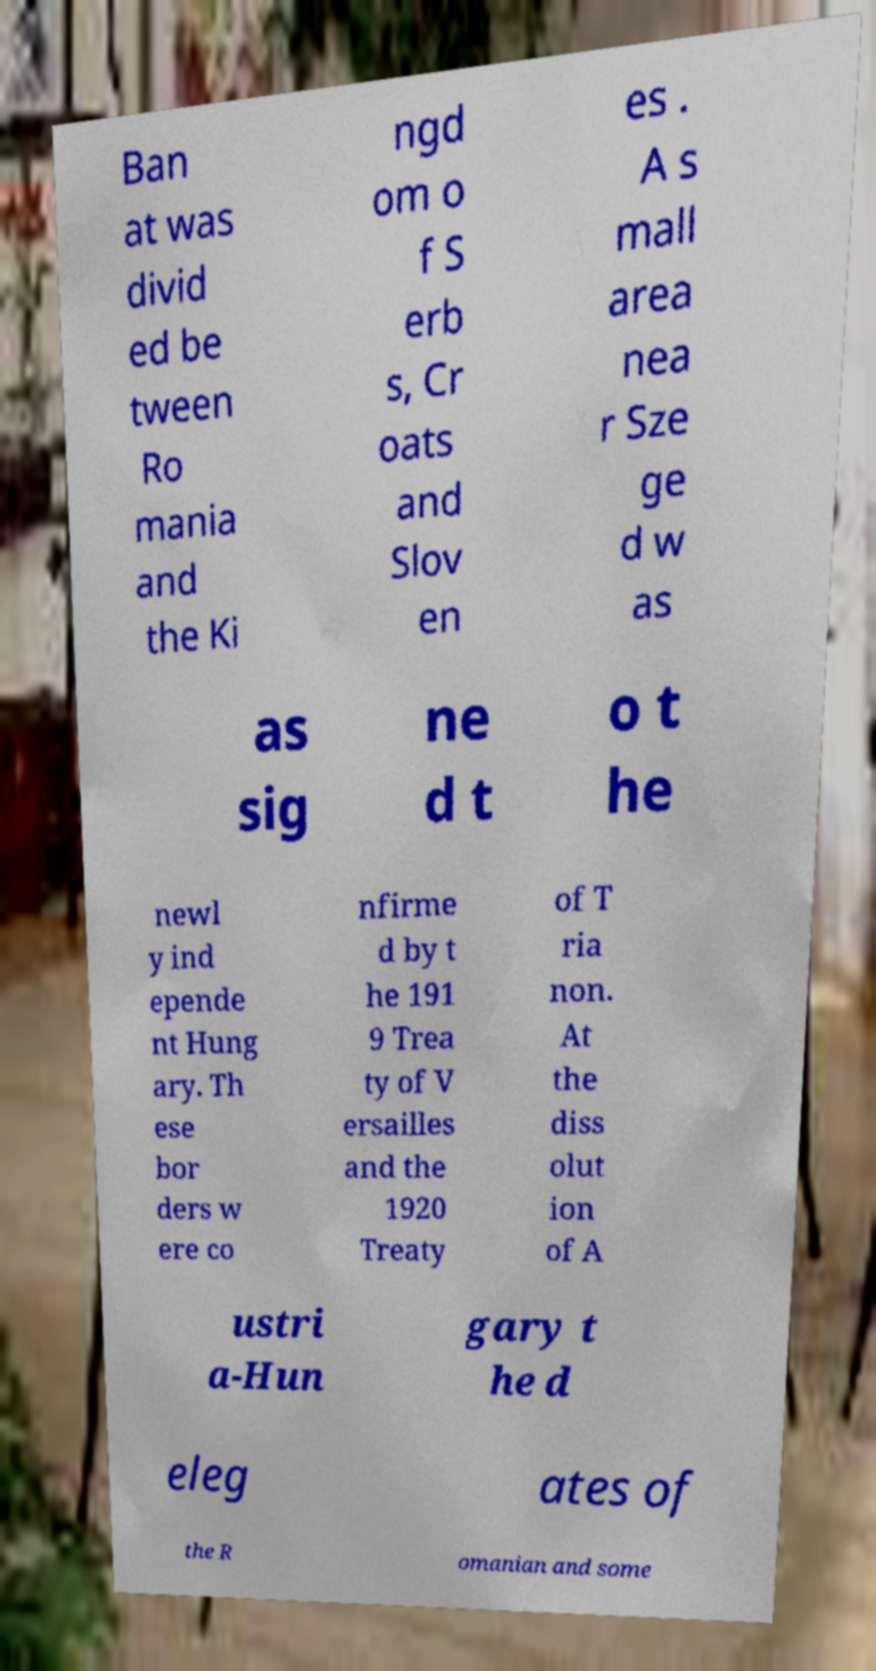For documentation purposes, I need the text within this image transcribed. Could you provide that? Ban at was divid ed be tween Ro mania and the Ki ngd om o f S erb s, Cr oats and Slov en es . A s mall area nea r Sze ge d w as as sig ne d t o t he newl y ind epende nt Hung ary. Th ese bor ders w ere co nfirme d by t he 191 9 Trea ty of V ersailles and the 1920 Treaty of T ria non. At the diss olut ion of A ustri a-Hun gary t he d eleg ates of the R omanian and some 